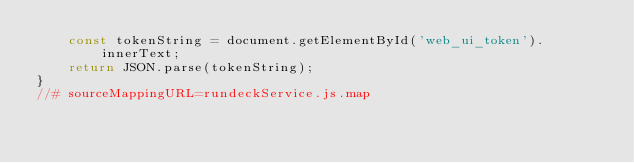<code> <loc_0><loc_0><loc_500><loc_500><_JavaScript_>    const tokenString = document.getElementById('web_ui_token').innerText;
    return JSON.parse(tokenString);
}
//# sourceMappingURL=rundeckService.js.map</code> 